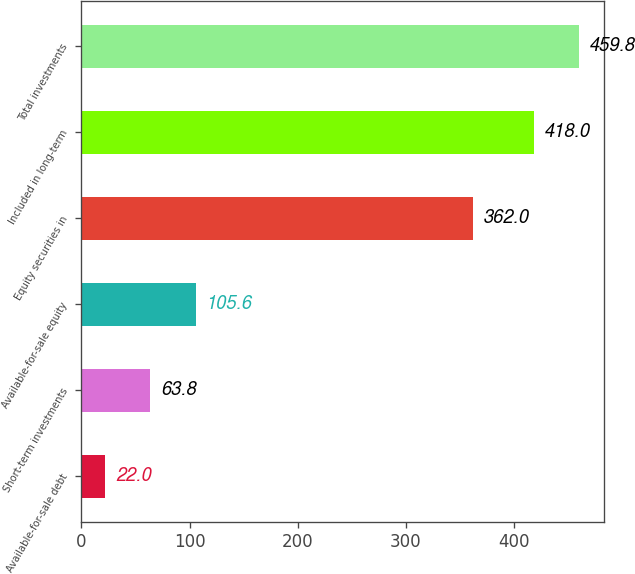Convert chart. <chart><loc_0><loc_0><loc_500><loc_500><bar_chart><fcel>Available-for-sale debt<fcel>Short-term investments<fcel>Available-for-sale equity<fcel>Equity securities in<fcel>Included in long-term<fcel>Total investments<nl><fcel>22<fcel>63.8<fcel>105.6<fcel>362<fcel>418<fcel>459.8<nl></chart> 